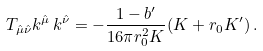<formula> <loc_0><loc_0><loc_500><loc_500>T _ { \hat { \mu } \hat { \nu } } k ^ { \hat { \mu } } \, k ^ { \hat { \nu } } = - \frac { 1 - b ^ { \prime } } { 1 6 \pi r _ { 0 } ^ { 2 } K } ( K + r _ { 0 } K ^ { \prime } ) \, .</formula> 